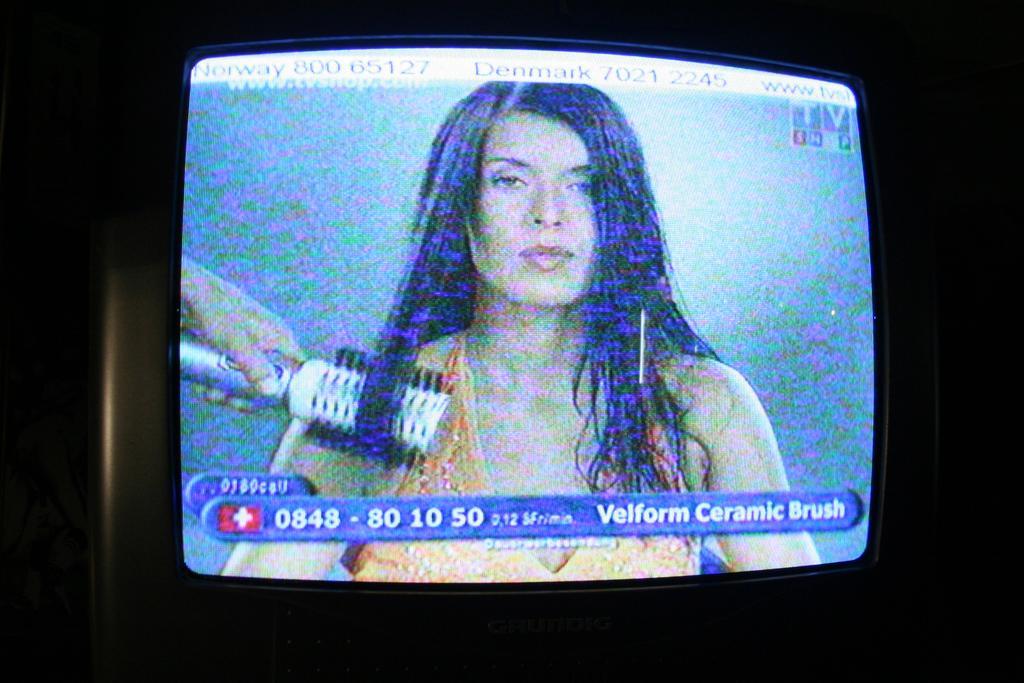Can you describe this image briefly? Here we can see screen,in this screen we can see a woman and we can see an object hold with hand. In the background it is dark. 